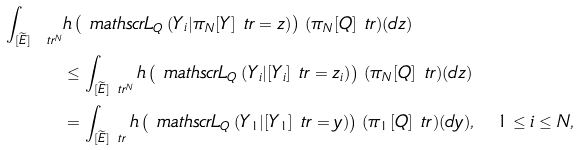Convert formula to latex. <formula><loc_0><loc_0><loc_500><loc_500>\int _ { [ \widetilde { E } ] _ { \ } t r ^ { N } } & h \left ( \ m a t h s c r { L } _ { Q } \left ( Y _ { i } | \pi _ { N } [ Y ] _ { \ } t r = z \right ) \right ) \, ( \pi _ { N } [ Q ] _ { \ } t r ) ( d z ) \\ & \leq \int _ { [ \widetilde { E } ] _ { \ } t r ^ { N } } h \left ( \ m a t h s c r { L } _ { Q } \left ( Y _ { i } | [ Y _ { i } ] _ { \ } t r = z _ { i } \right ) \right ) \, ( \pi _ { N } [ Q ] _ { \ } t r ) ( d z ) \\ & = \int _ { [ \widetilde { E } ] _ { \ } t r } h \left ( \ m a t h s c r { L } _ { Q } \left ( Y _ { 1 } | [ Y _ { 1 } ] _ { \ } t r = y \right ) \right ) \, ( \pi _ { 1 } [ Q ] _ { \ } t r ) ( d y ) , \quad 1 \leq i \leq N ,</formula> 